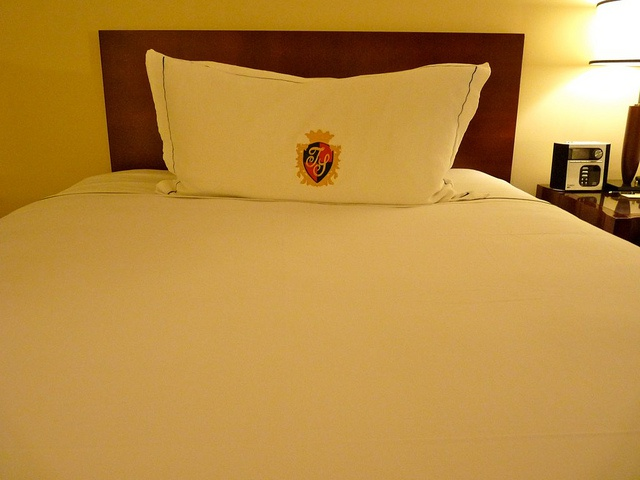Describe the objects in this image and their specific colors. I can see bed in tan, olive, maroon, and orange tones and clock in olive, black, and tan tones in this image. 